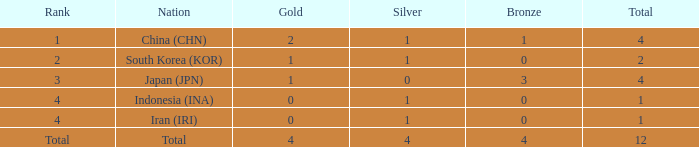For a nation with under one gold medal and a total of less than one, how many silver medals do they possess? 0.0. 